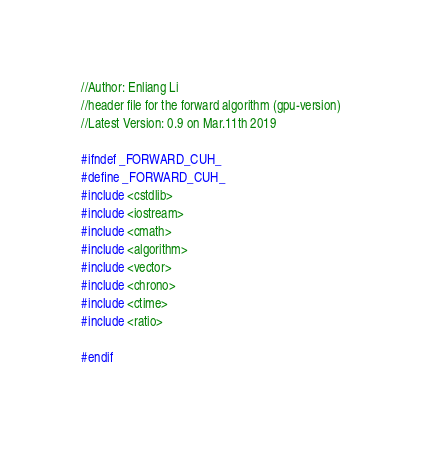<code> <loc_0><loc_0><loc_500><loc_500><_Cuda_>//Author: Enliang Li
//header file for the forward algorithm (gpu-version)
//Latest Version: 0.9 on Mar.11th 2019

#ifndef _FORWARD_CUH_
#define _FORWARD_CUH_
#include <cstdlib>
#include <iostream>
#include <cmath>
#include <algorithm>
#include <vector>
#include <chrono>
#include <ctime>
#include <ratio>

#endif
</code> 